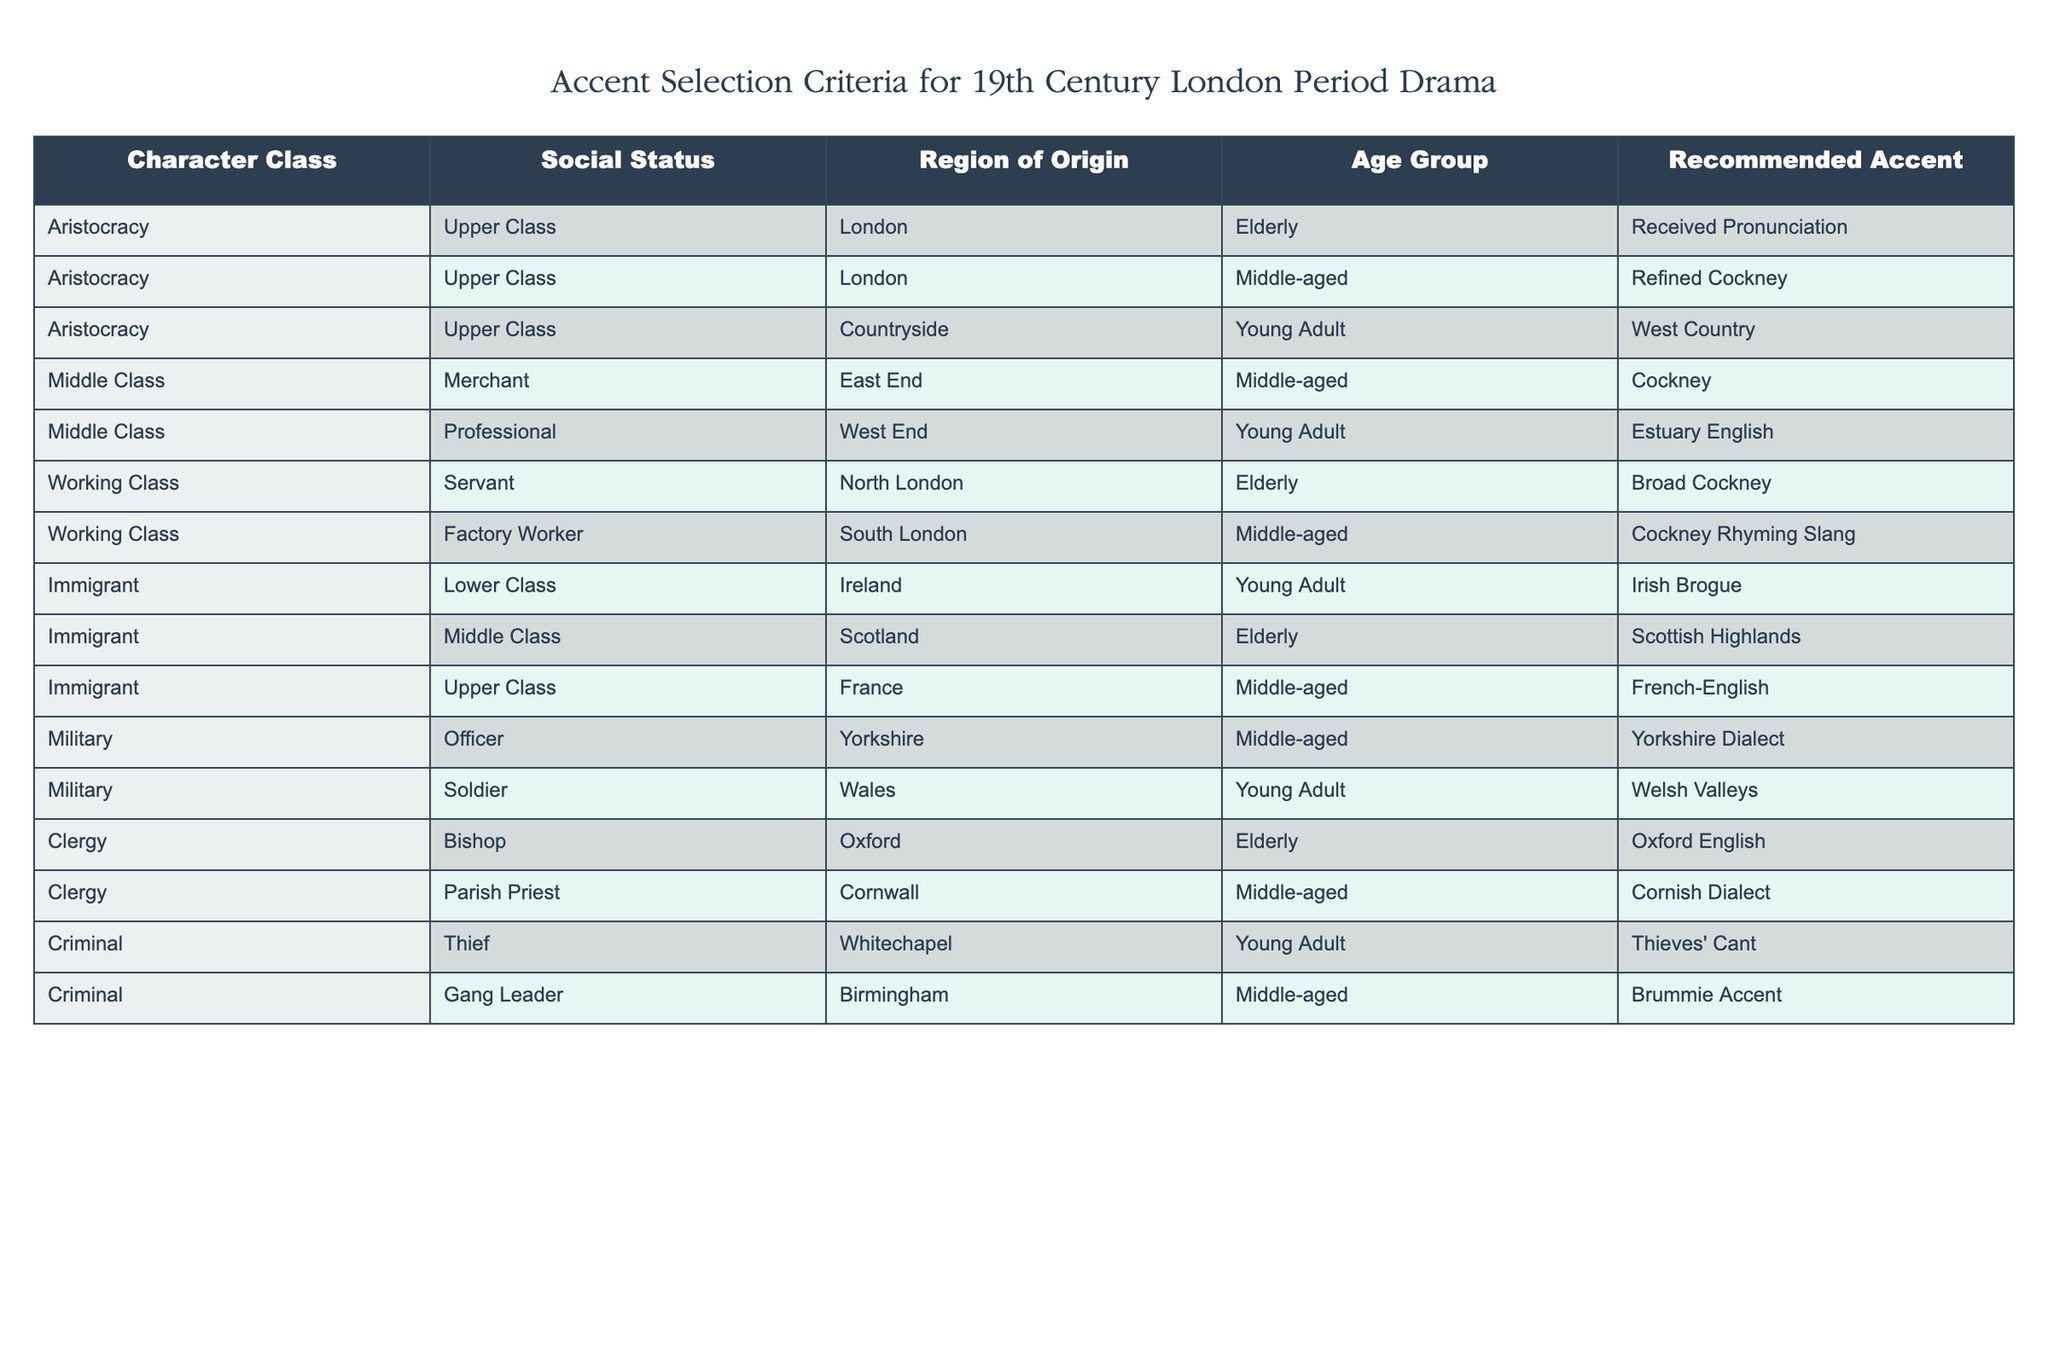What accent is recommended for elderly characters from the aristocracy? The table indicates that elderly characters from the aristocracy, particularly those from London, are recommended to use the Received Pronunciation accent.
Answer: Received Pronunciation How many accent recommendations correspond to middle-aged characters? By counting the rows in the table, there are five entries corresponding to middle-aged characters: Refined Cockney (Upper Class, London), Cockney (Middle Class, Merchant), Estuary English (Middle Class, Professional), Cornish Dialect (Clergy, Parish Priest), and Brummie Accent (Criminal, Gang Leader). Thus, the total is five.
Answer: 5 Is it true that all characters from the working class use Cockney accents? From the table, we see two accents are listed for working-class characters: Broad Cockney for the elderly servant and Cockney Rhyming Slang for the middle-aged factory worker. Therefore, it is not true that all working-class characters use Cockney accents since the elderly servant has a broader Cockney accent.
Answer: No Which region of origin has the most accent recommendations? The table shows that "London" is listed under the first three entries for accents (Received Pronunciation, Refined Cockney, and Cockney) along with another entry for "East End" (Cockney). Other regions like "Countryside" and "Yorkshire" have fewer accent recommendations. Thus, London has the most with three recommendations.
Answer: London What is the average social status of characters recommended for the Irish Brogue accent? There is only one entry for characters with the Irish Brogue, which is for a young adult immigrant classified as lower class. As there is a single point of reference, the average social status cannot be computed; the status for this character is simply lower class.
Answer: Lower class 